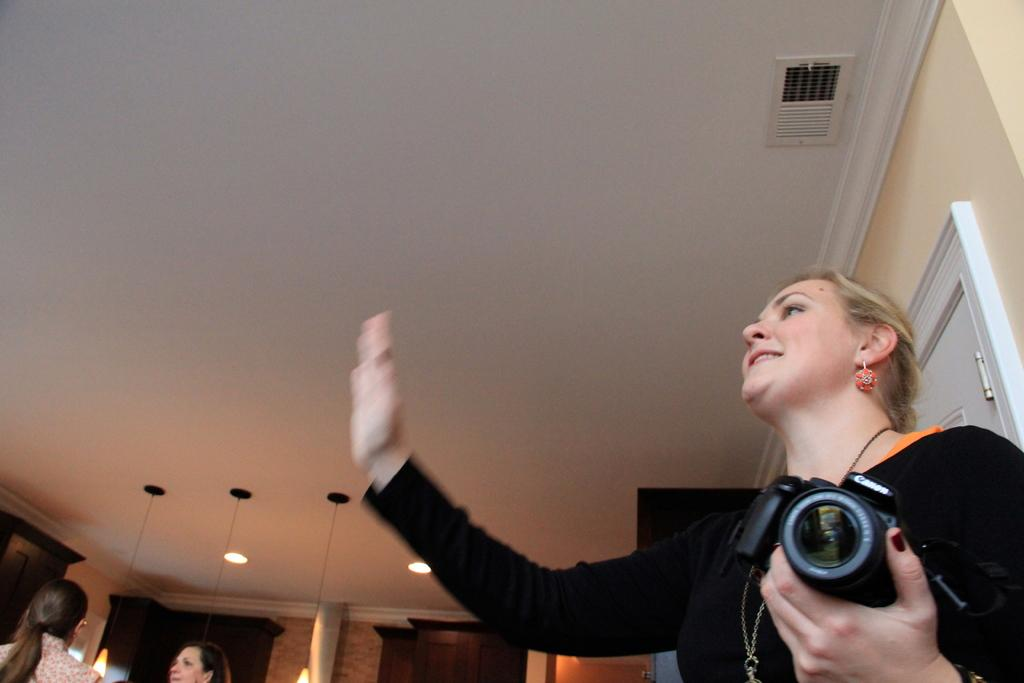Who is the main subject in the image? There is a woman in the image. What is the woman wearing? The woman is wearing a black dress. What is the woman holding in the image? The woman is holding a camera. How many other persons are present in the image? There are two other persons beside the woman. What type of notebook is the woman using to take notes in the image? There is no notebook present in the image; the woman is holding a camera. 